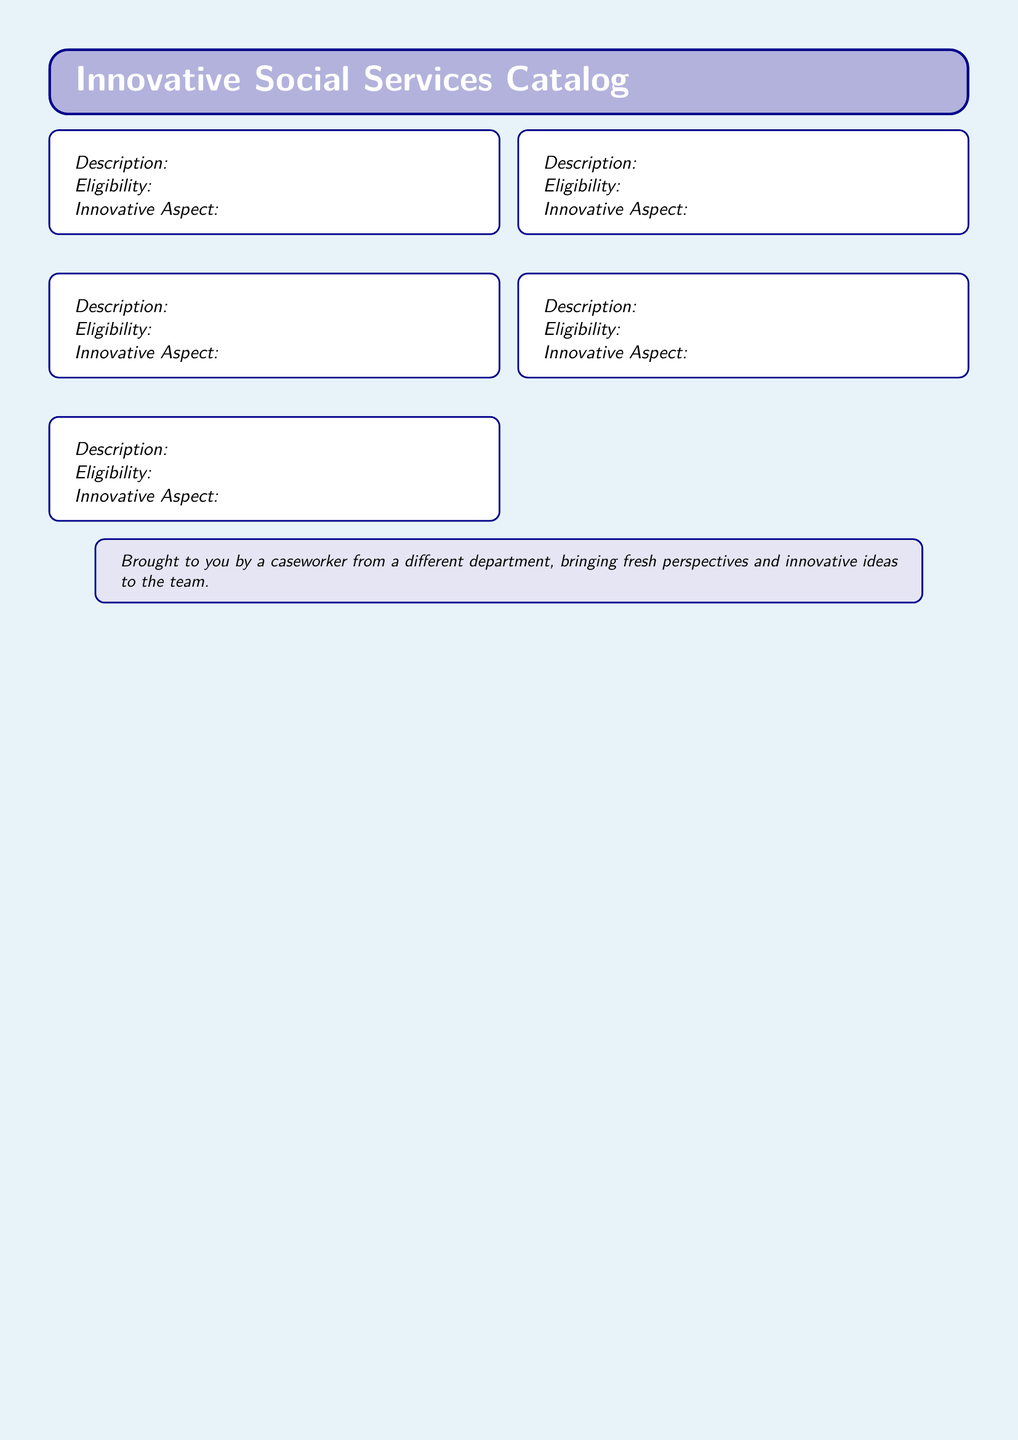What is the first program listed? The first program is named "Tech Literacy for Seniors," as indicated by the program list in the document.
Answer: Tech Literacy for Seniors What is the age eligibility for the Green Jobs Initiative? The eligibility criteria state that participants must be aged 18-55, according to the program description in the document.
Answer: 18-55 What unique aspect does the Mobile Mental Health Clinic offer? The innovative aspect highlights that it brings professional services directly to underserved communities.
Answer: Eliminating transportation barriers How many programs are listed in this catalog? The document details five innovative social services programs, as evidenced by the structure of the document.
Answer: 5 What is the description of the Vertical Urban Farming Project? The description states that it converts unused urban spaces into vertical gardens, which provides fresh produce and job opportunities.
Answer: Converts unused urban spaces into vertical gardens What is a requirement for participating in the Skill Swap Network? The eligibility criteria require all participants to have a verifiable skill to share, according to the details provided.
Answer: A verifiable skill to share In what way does the Green Jobs Initiative address social issues? The innovative aspect explains that it combines environmental sustainability with workforce development, thus addressing two issues.
Answer: Combining environmental sustainability with workforce development What type of participants does the Mobile Mental Health Clinic serve? The eligibility specifies that it serves residents in designated low-income areas with mental health needs.
Answer: Underserved communities 